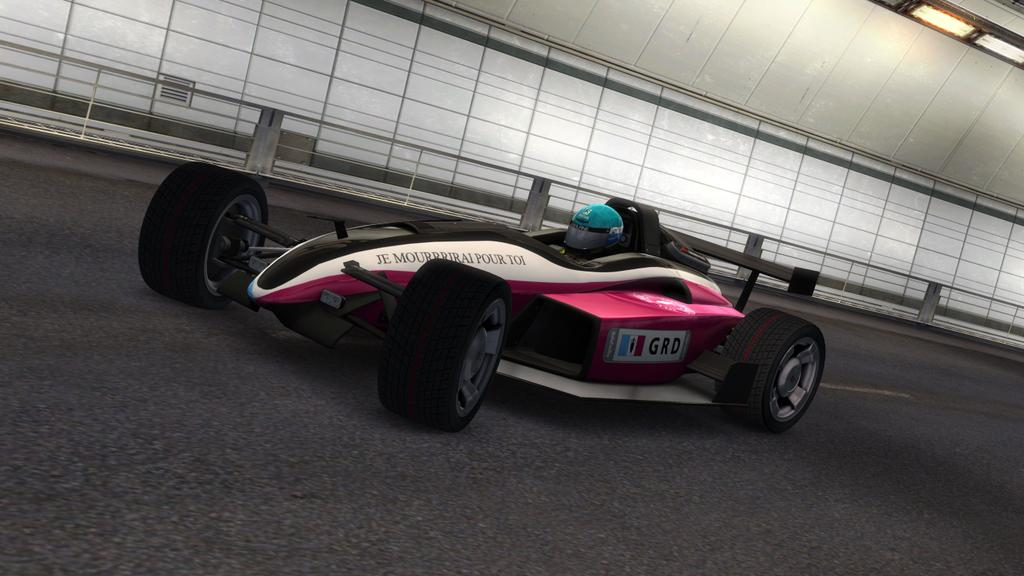What is on the road in the image? There is a vehicle on the road in the image. Who is on the vehicle? A person is sitting on the vehicle. What safety precaution is the person taking? The person is wearing a helmet. What can be seen in the distance in the image? There are walls, lights, and other objects visible in the background of the image. What type of alarm is going off in the image? There is no alarm present in the image. What kind of treatment is being administered to the person on the vehicle? There is no treatment being administered to the person on the vehicle in the image. 